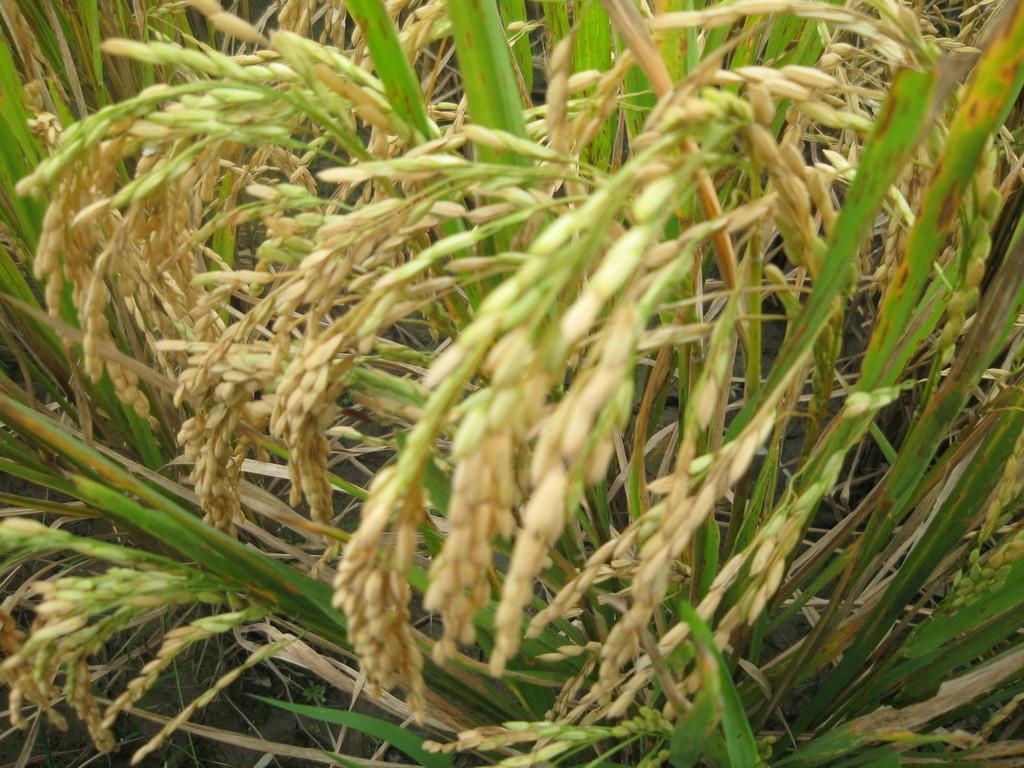In one or two sentences, can you explain what this image depicts? In this image we can see some paddy crops. 